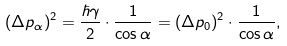Convert formula to latex. <formula><loc_0><loc_0><loc_500><loc_500>( \Delta p _ { \alpha } ) ^ { 2 } = \frac { \hbar { \gamma } } { 2 } \cdot \frac { 1 } { \cos \alpha } = ( \Delta p _ { 0 } ) ^ { 2 } \cdot \frac { 1 } { \cos \alpha } ,</formula> 